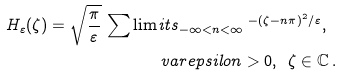<formula> <loc_0><loc_0><loc_500><loc_500>H _ { \varepsilon } ( \zeta ) = \sqrt { \frac { \pi } { \varepsilon } } \, \sum \lim i t s _ { - \infty < n < \infty } \, ^ { - ( \zeta - n \pi ) ^ { 2 } / \varepsilon } , \ \\ v a r e p s i l o n > 0 , \ \, \zeta \in \mathbb { C } \, .</formula> 